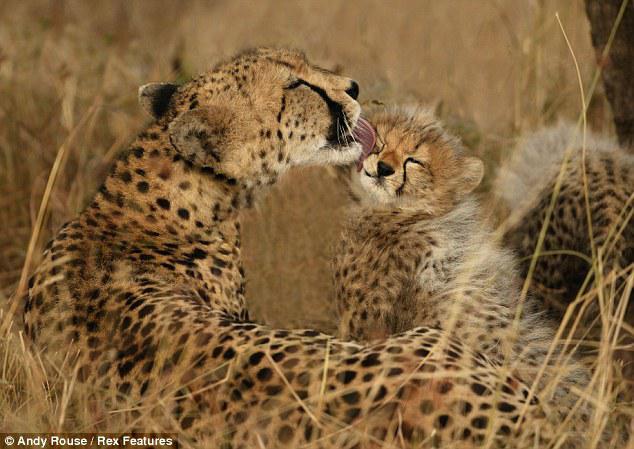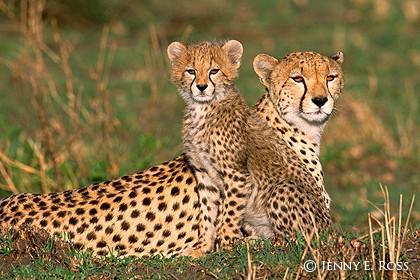The first image is the image on the left, the second image is the image on the right. For the images shown, is this caption "Each image shows exactly two cheetahs." true? Answer yes or no. Yes. 